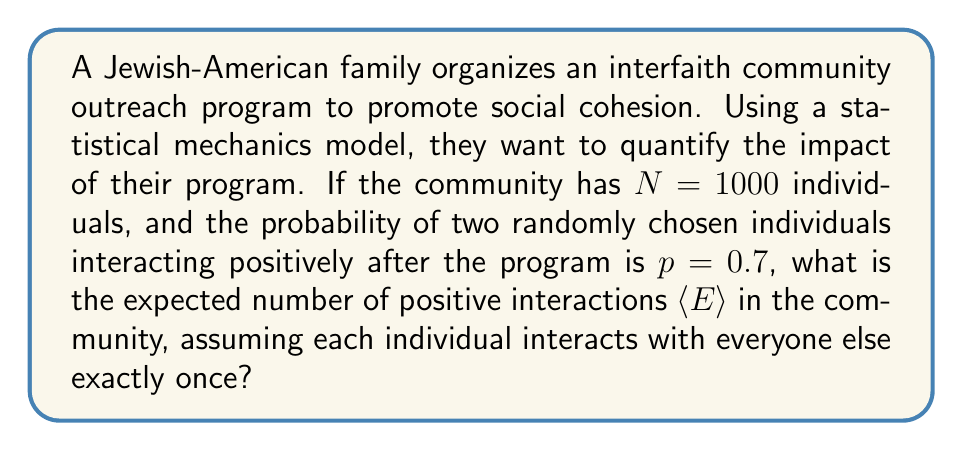Help me with this question. To solve this problem, we'll use concepts from statistical mechanics applied to social interactions:

1) In this model, each individual can be considered a "particle" in the system.

2) The total number of possible interactions in the community is given by:
   $$\binom{N}{2} = \frac{N(N-1)}{2}$$

3) Each interaction has a probability $p$ of being positive.

4) The expected number of positive interactions $\langle E \rangle$ can be calculated using:
   $$\langle E \rangle = p \cdot \binom{N}{2}$$

5) Substituting the given values:
   $$\langle E \rangle = 0.7 \cdot \frac{1000(1000-1)}{2}$$

6) Simplify:
   $$\langle E \rangle = 0.7 \cdot \frac{1000 \cdot 999}{2} = 0.7 \cdot 499500 = 349650$$

Therefore, the expected number of positive interactions in the community after the program is 349,650.
Answer: 349,650 